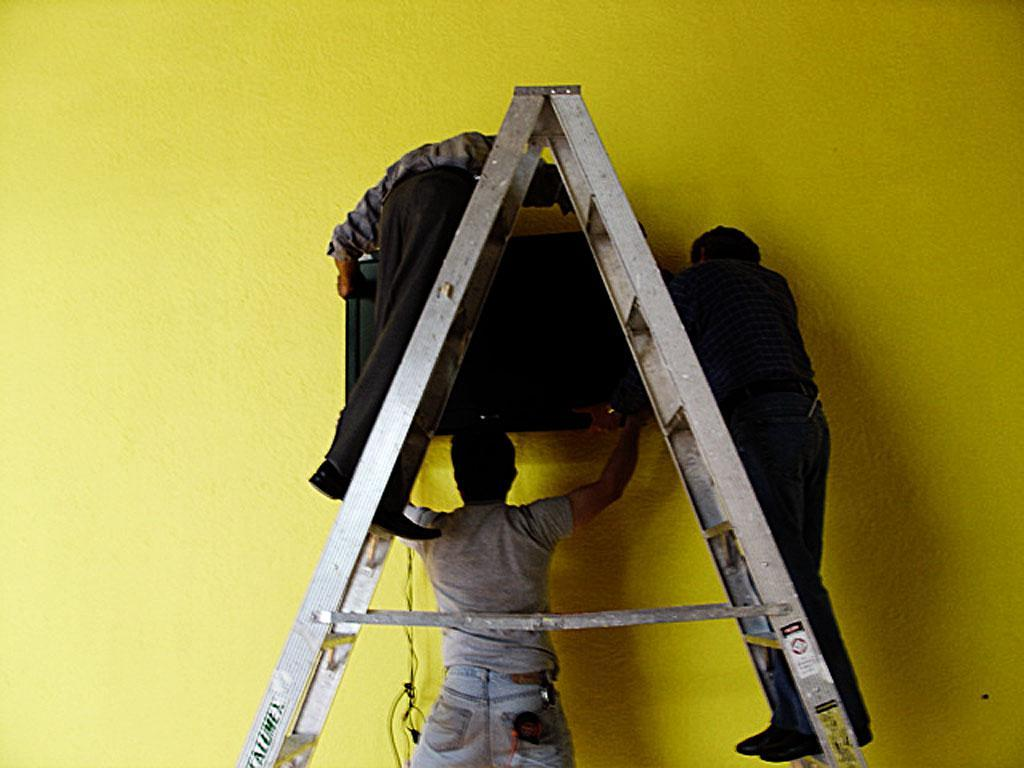What is the person in the image holding? The person is holding a television. What are the other two persons in the image doing? The other two persons are standing on a ladder. What can be seen in the background of the image? There is a wall visible in the background of the image. What park can be seen in the background of the image? There is no park visible in the background of the image; it features a wall instead. What is the person's interest in holding the television in the image? The image does not provide information about the person's interest or motivation for holding the television. 